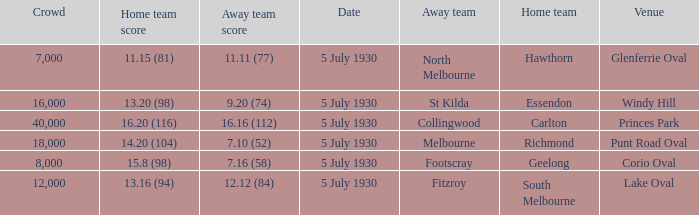What day does the team play at punt road oval? 5 July 1930. Would you mind parsing the complete table? {'header': ['Crowd', 'Home team score', 'Away team score', 'Date', 'Away team', 'Home team', 'Venue'], 'rows': [['7,000', '11.15 (81)', '11.11 (77)', '5 July 1930', 'North Melbourne', 'Hawthorn', 'Glenferrie Oval'], ['16,000', '13.20 (98)', '9.20 (74)', '5 July 1930', 'St Kilda', 'Essendon', 'Windy Hill'], ['40,000', '16.20 (116)', '16.16 (112)', '5 July 1930', 'Collingwood', 'Carlton', 'Princes Park'], ['18,000', '14.20 (104)', '7.10 (52)', '5 July 1930', 'Melbourne', 'Richmond', 'Punt Road Oval'], ['8,000', '15.8 (98)', '7.16 (58)', '5 July 1930', 'Footscray', 'Geelong', 'Corio Oval'], ['12,000', '13.16 (94)', '12.12 (84)', '5 July 1930', 'Fitzroy', 'South Melbourne', 'Lake Oval']]} 